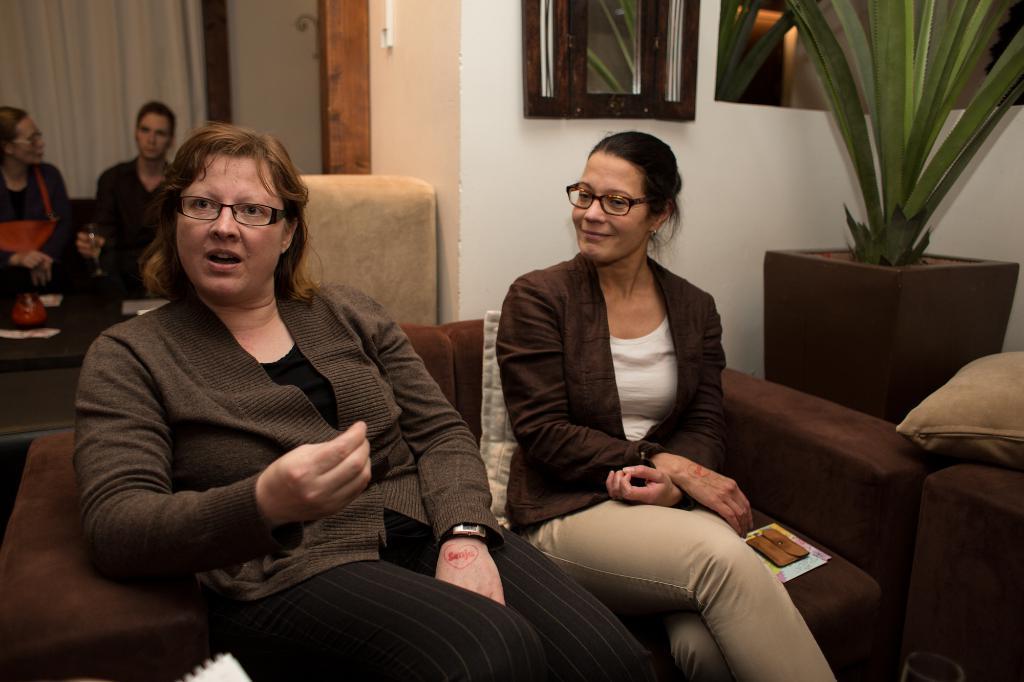Could you give a brief overview of what you see in this image? In this picture we can see four persons are sitting on the sofa. This is pillow. And there is a plant. Here we can see a curtain and this is wall. 